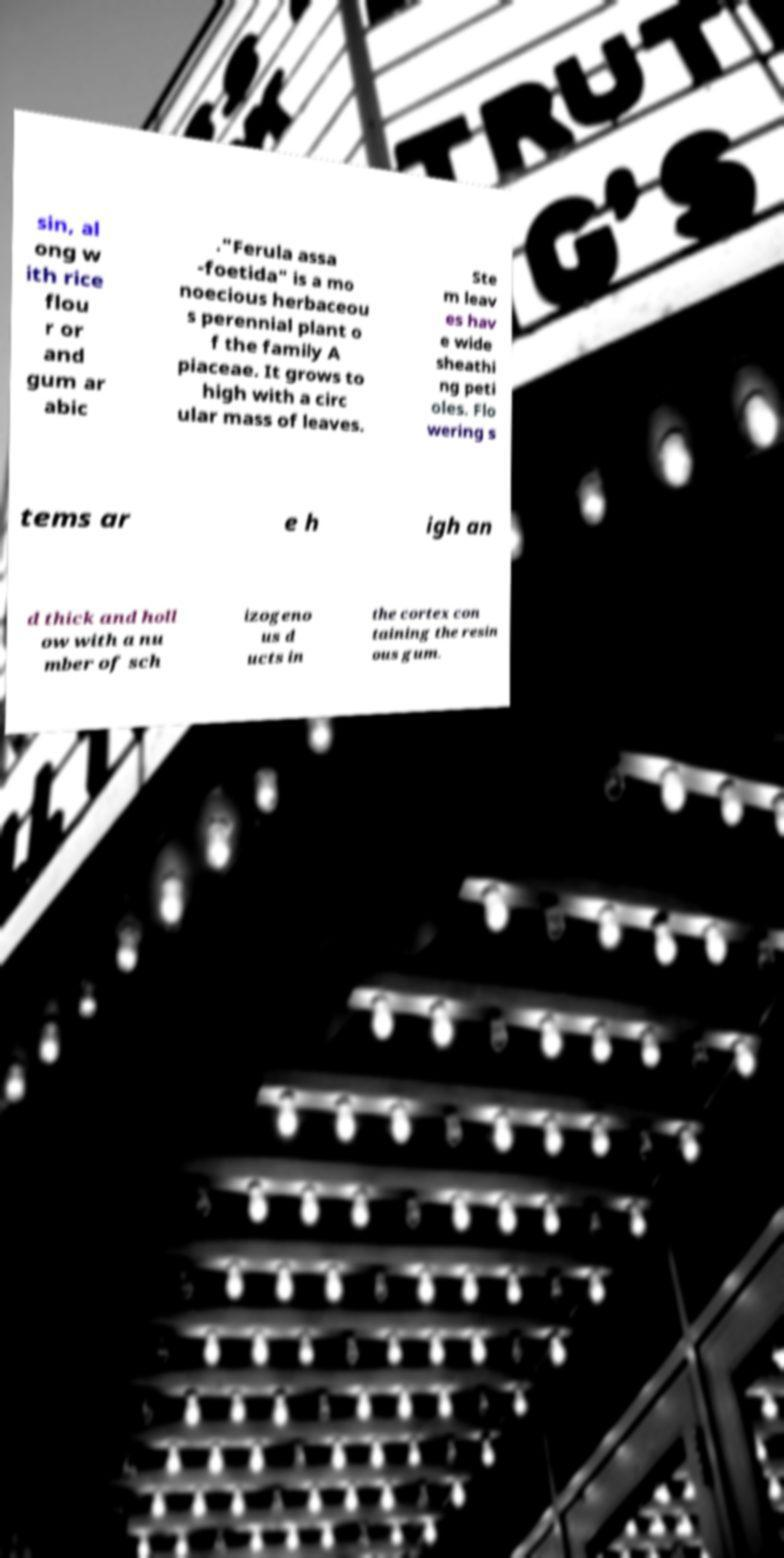For documentation purposes, I need the text within this image transcribed. Could you provide that? sin, al ong w ith rice flou r or and gum ar abic ."Ferula assa -foetida" is a mo noecious herbaceou s perennial plant o f the family A piaceae. It grows to high with a circ ular mass of leaves. Ste m leav es hav e wide sheathi ng peti oles. Flo wering s tems ar e h igh an d thick and holl ow with a nu mber of sch izogeno us d ucts in the cortex con taining the resin ous gum. 